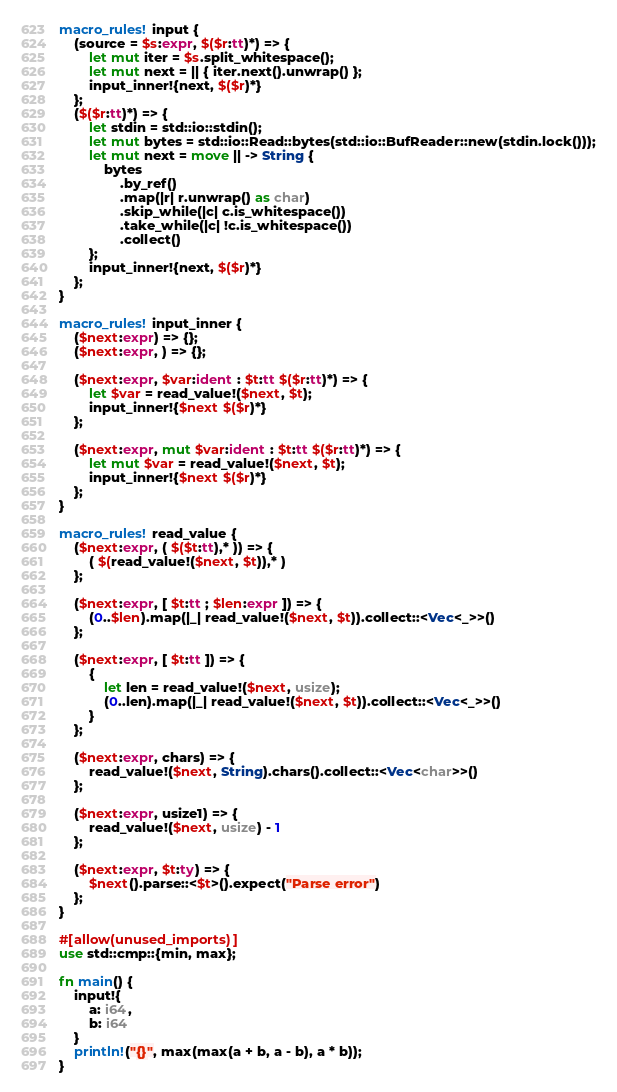Convert code to text. <code><loc_0><loc_0><loc_500><loc_500><_Rust_>macro_rules! input {
    (source = $s:expr, $($r:tt)*) => {
        let mut iter = $s.split_whitespace();
        let mut next = || { iter.next().unwrap() };
        input_inner!{next, $($r)*}
    };
    ($($r:tt)*) => {
        let stdin = std::io::stdin();
        let mut bytes = std::io::Read::bytes(std::io::BufReader::new(stdin.lock()));
        let mut next = move || -> String {
            bytes
                .by_ref()
                .map(|r| r.unwrap() as char)
                .skip_while(|c| c.is_whitespace())
                .take_while(|c| !c.is_whitespace())
                .collect()
        };
        input_inner!{next, $($r)*}
    };
}

macro_rules! input_inner {
    ($next:expr) => {};
    ($next:expr, ) => {};

    ($next:expr, $var:ident : $t:tt $($r:tt)*) => {
        let $var = read_value!($next, $t);
        input_inner!{$next $($r)*}
    };

    ($next:expr, mut $var:ident : $t:tt $($r:tt)*) => {
        let mut $var = read_value!($next, $t);
        input_inner!{$next $($r)*}
    };
}

macro_rules! read_value {
    ($next:expr, ( $($t:tt),* )) => {
        ( $(read_value!($next, $t)),* )
    };

    ($next:expr, [ $t:tt ; $len:expr ]) => {
        (0..$len).map(|_| read_value!($next, $t)).collect::<Vec<_>>()
    };

    ($next:expr, [ $t:tt ]) => {
        {
            let len = read_value!($next, usize);
            (0..len).map(|_| read_value!($next, $t)).collect::<Vec<_>>()
        }
    };

    ($next:expr, chars) => {
        read_value!($next, String).chars().collect::<Vec<char>>()
    };

    ($next:expr, usize1) => {
        read_value!($next, usize) - 1
    };

    ($next:expr, $t:ty) => {
        $next().parse::<$t>().expect("Parse error")
    };
}

#[allow(unused_imports)]
use std::cmp::{min, max};

fn main() {
    input!{
        a: i64,
        b: i64
    }
    println!("{}", max(max(a + b, a - b), a * b));
}
</code> 